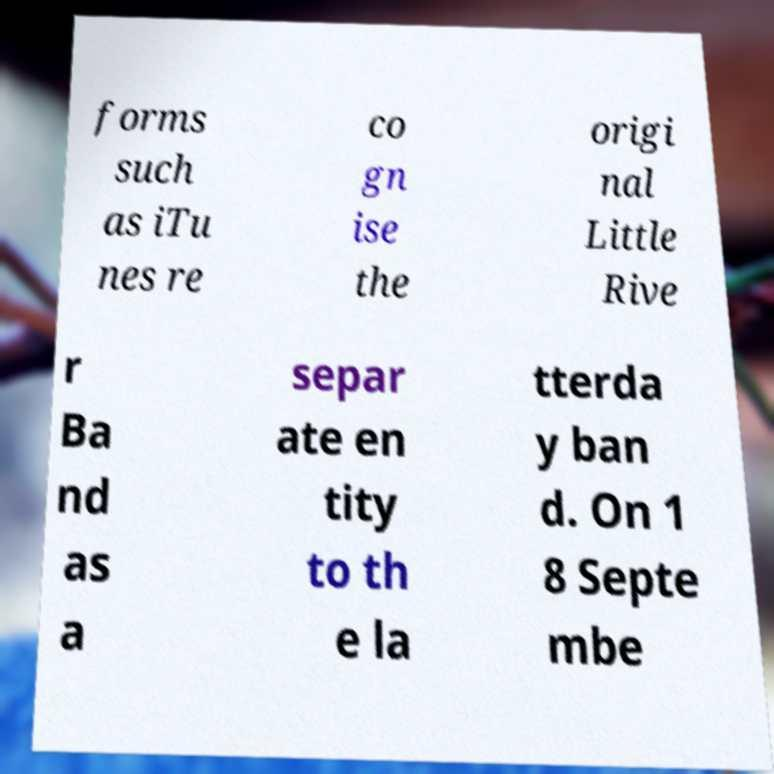Please read and relay the text visible in this image. What does it say? forms such as iTu nes re co gn ise the origi nal Little Rive r Ba nd as a separ ate en tity to th e la tterda y ban d. On 1 8 Septe mbe 